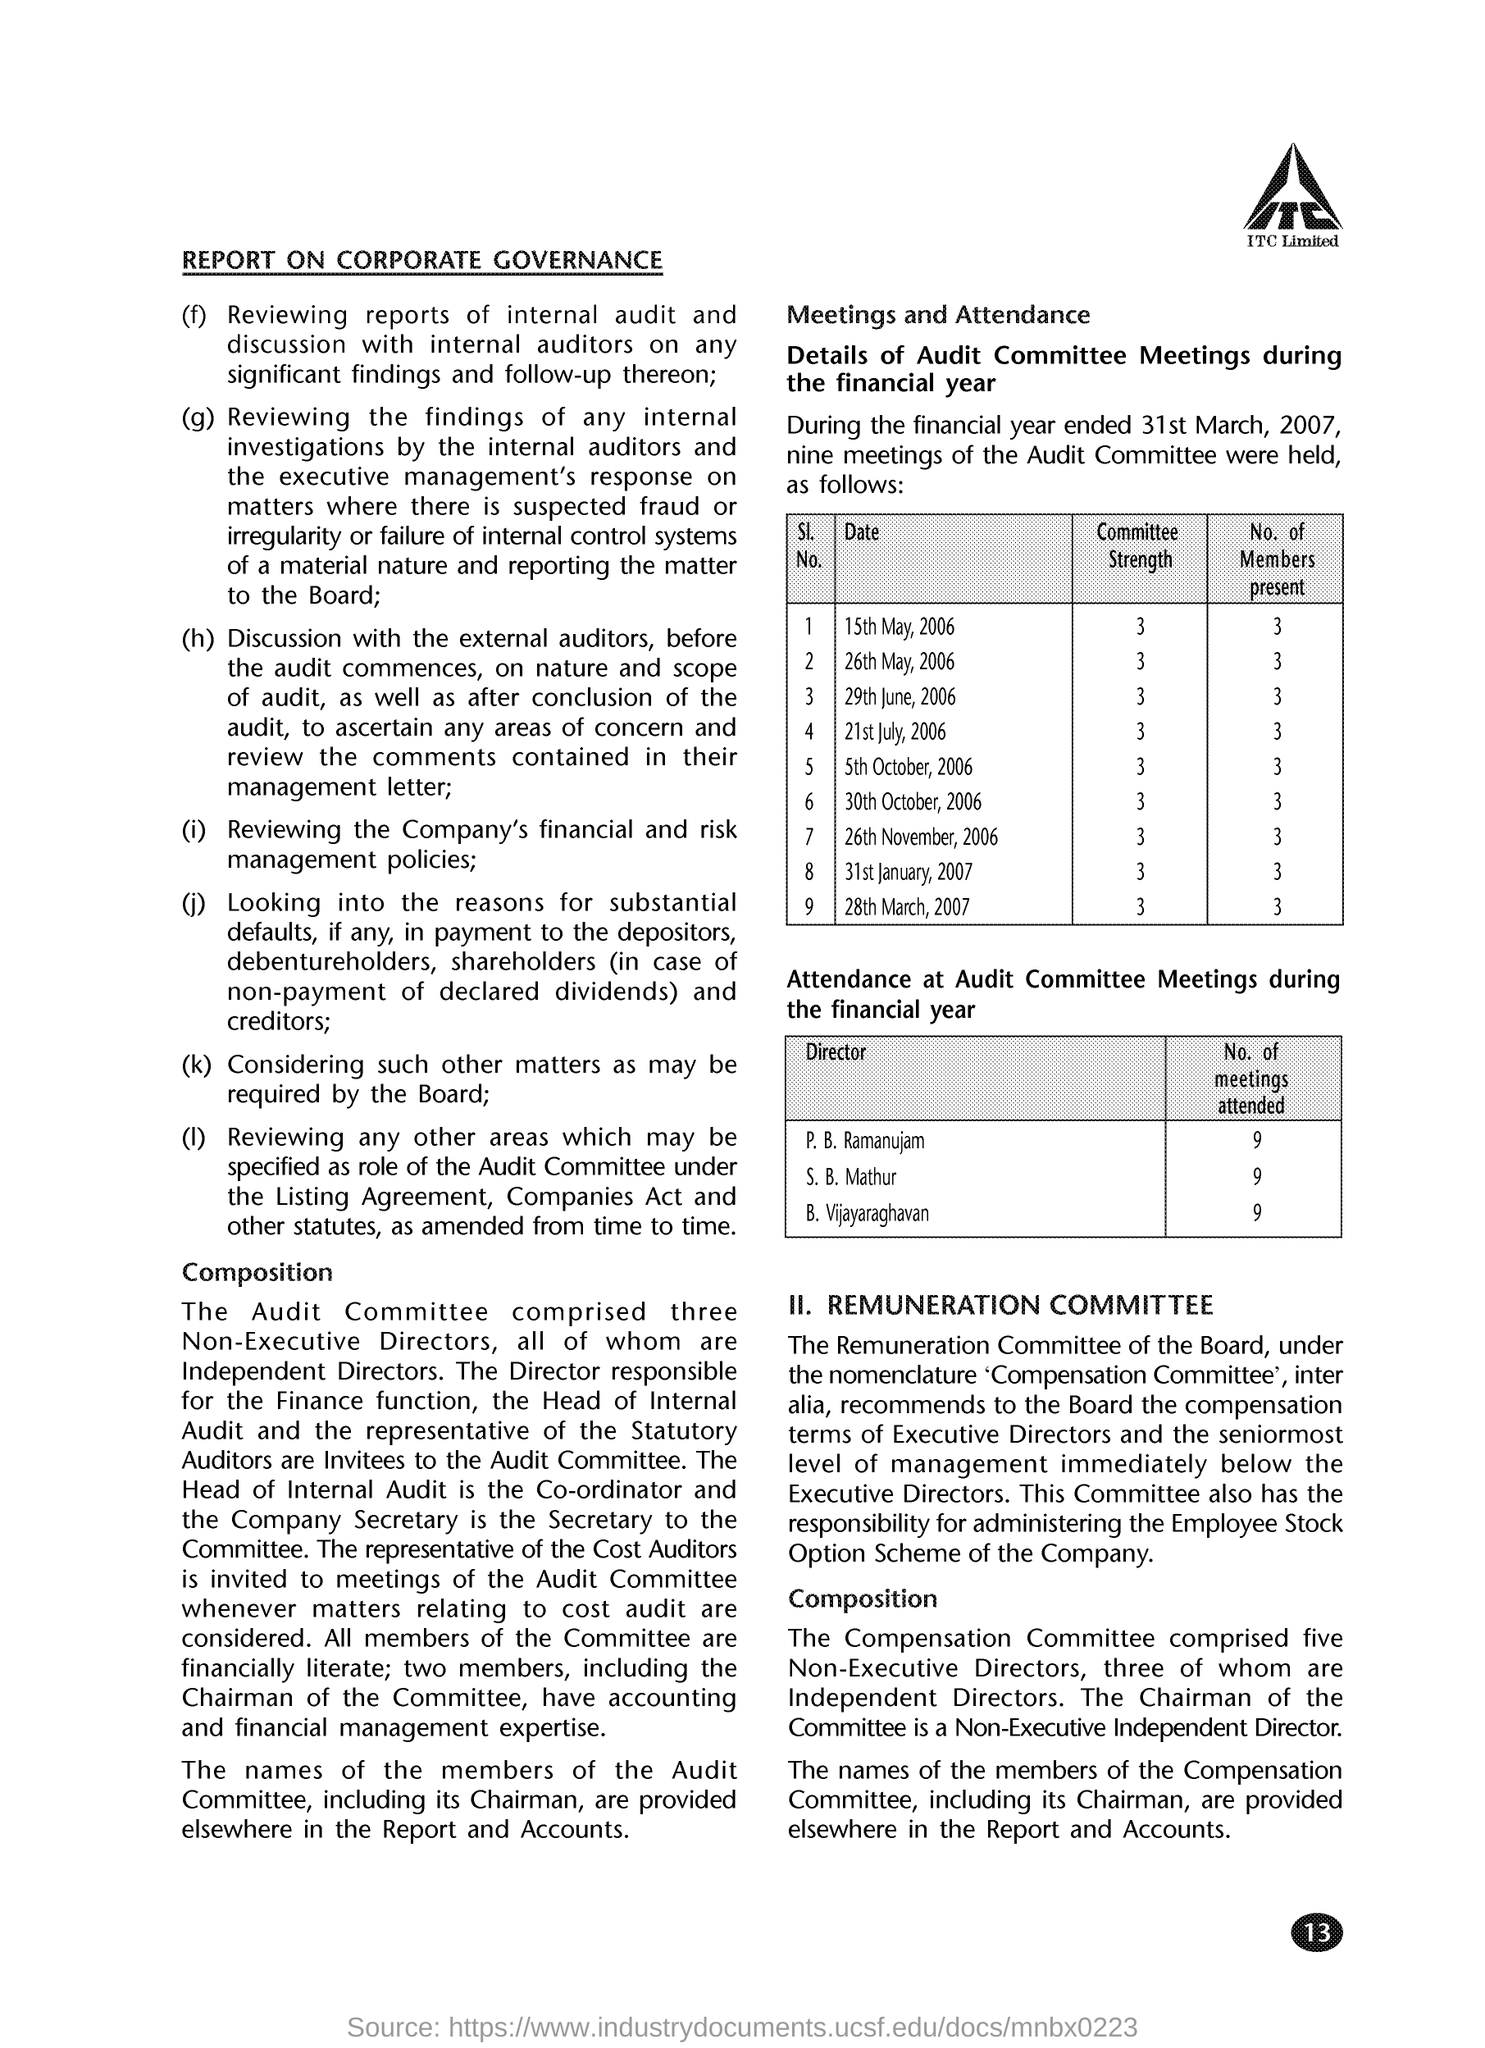Give some essential details in this illustration. The page number mentioned in this document is 13. On May 15th, 2006, there were 3 members present at the Audit Committee Meetings. The representative of the Cost Auditors is invited to Audit Committee Meetings whenever matters relating to cost audit are considered. During the financial year ending on March 31, 2007, B. Vijayaraghavan attended 9 Audit Committee Meetings. The number of members present at the Audit Committee Meetings held on 21st July, 2006 was 3. 